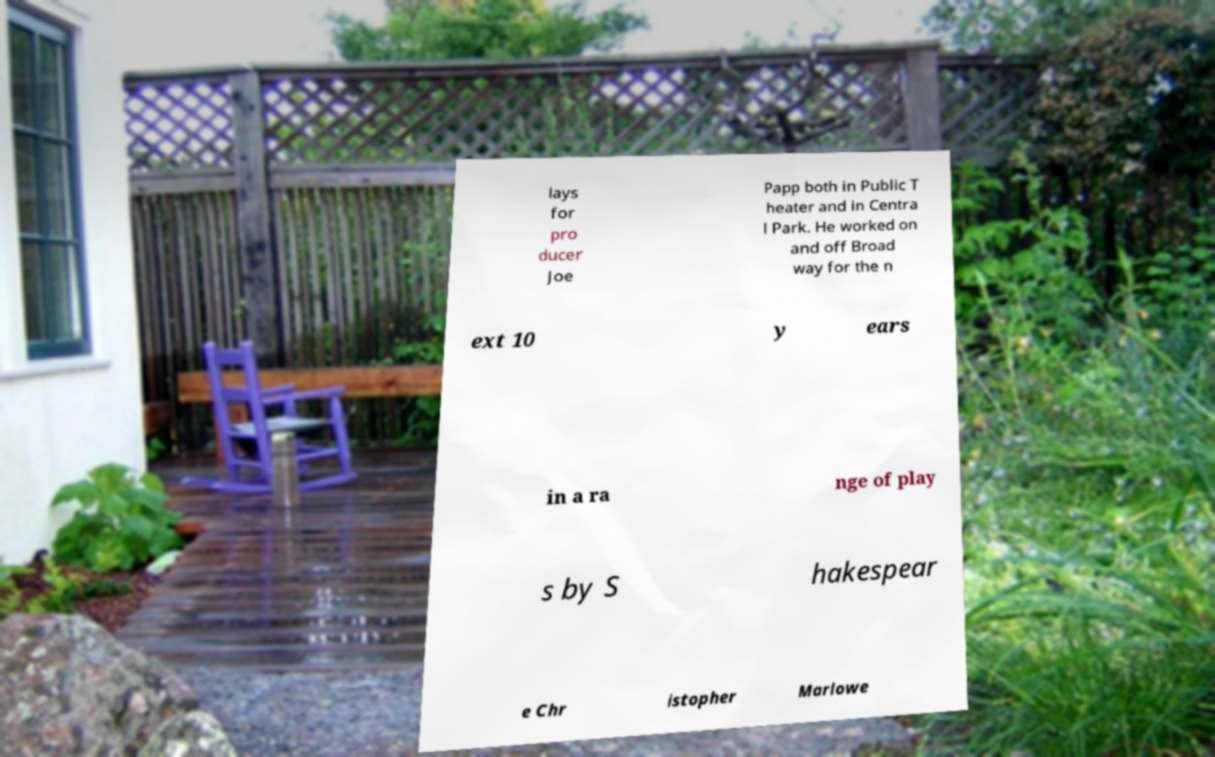Could you assist in decoding the text presented in this image and type it out clearly? lays for pro ducer Joe Papp both in Public T heater and in Centra l Park. He worked on and off Broad way for the n ext 10 y ears in a ra nge of play s by S hakespear e Chr istopher Marlowe 